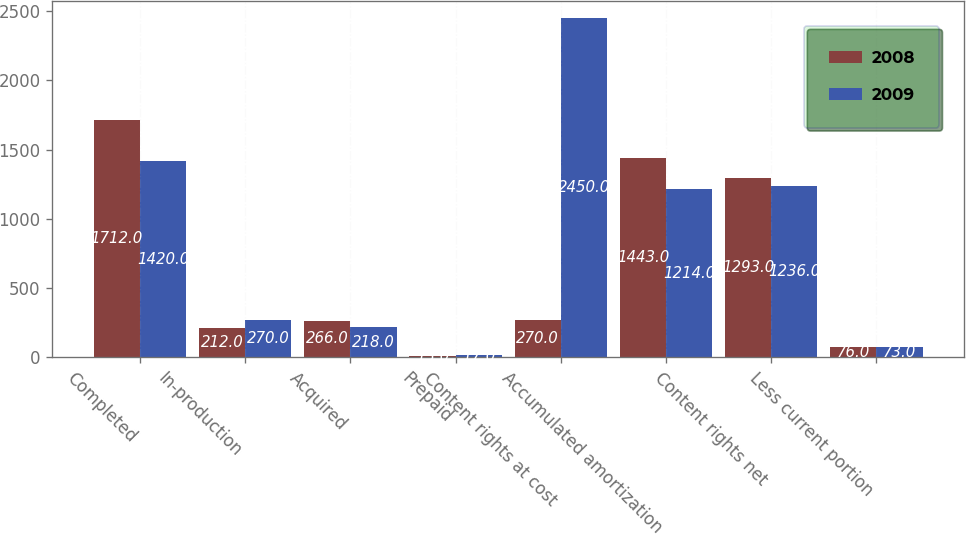Convert chart to OTSL. <chart><loc_0><loc_0><loc_500><loc_500><stacked_bar_chart><ecel><fcel>Completed<fcel>In-production<fcel>Acquired<fcel>Prepaid<fcel>Content rights at cost<fcel>Accumulated amortization<fcel>Content rights net<fcel>Less current portion<nl><fcel>2008<fcel>1712<fcel>212<fcel>266<fcel>13<fcel>270<fcel>1443<fcel>1293<fcel>76<nl><fcel>2009<fcel>1420<fcel>270<fcel>218<fcel>17<fcel>2450<fcel>1214<fcel>1236<fcel>73<nl></chart> 